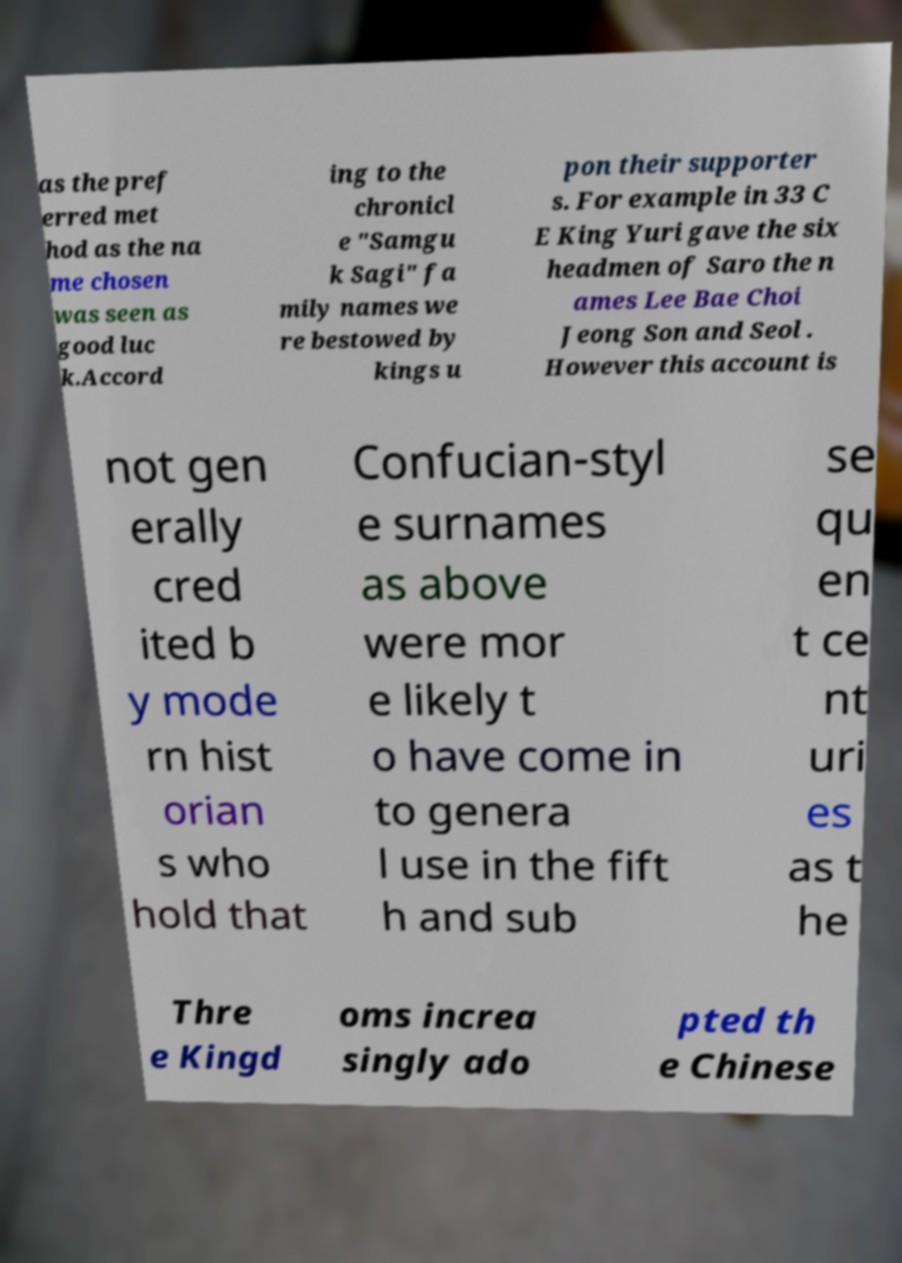Can you accurately transcribe the text from the provided image for me? as the pref erred met hod as the na me chosen was seen as good luc k.Accord ing to the chronicl e "Samgu k Sagi" fa mily names we re bestowed by kings u pon their supporter s. For example in 33 C E King Yuri gave the six headmen of Saro the n ames Lee Bae Choi Jeong Son and Seol . However this account is not gen erally cred ited b y mode rn hist orian s who hold that Confucian-styl e surnames as above were mor e likely t o have come in to genera l use in the fift h and sub se qu en t ce nt uri es as t he Thre e Kingd oms increa singly ado pted th e Chinese 